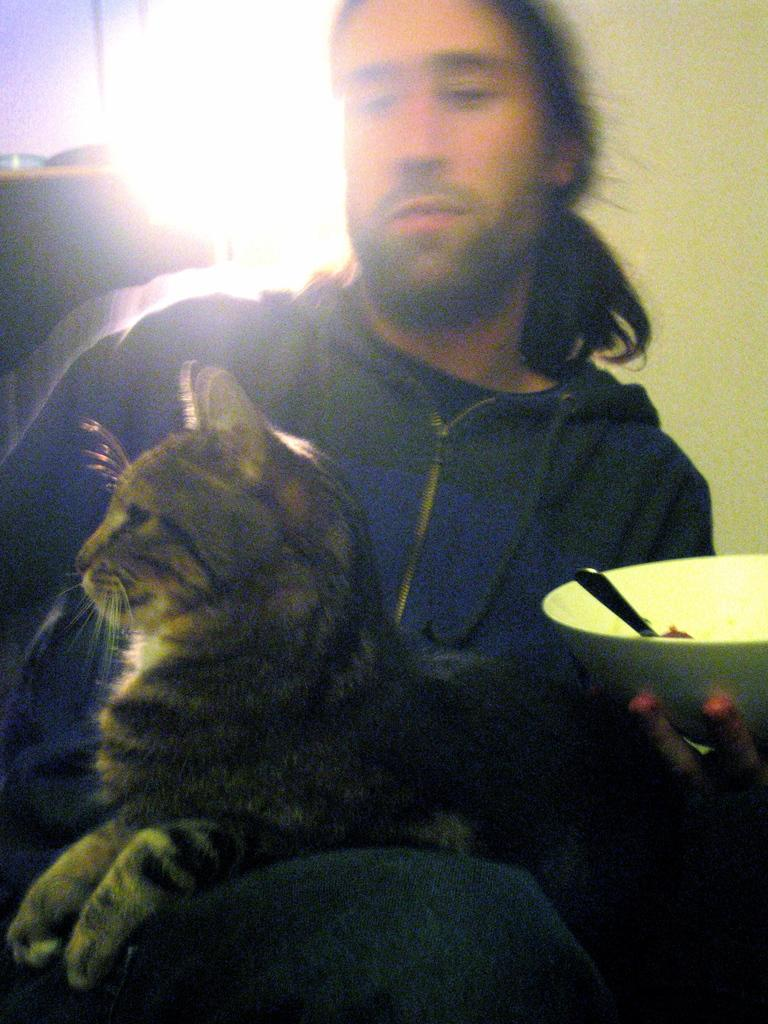What is the man in the image doing? There is a man sitting in the image. What is the man holding in his hand? The man has a bowl in his hand. Is there any other living creature present in the image? Yes, there is a cat sitting on the man. What type of parent is depicted in the image? There is no depiction of a parent in the image; it features a man sitting with a bowl and a cat. Can you tell me how many clouds are visible in the image? There is no mention of clouds in the image; it only features a man, a bowl, and a cat. 